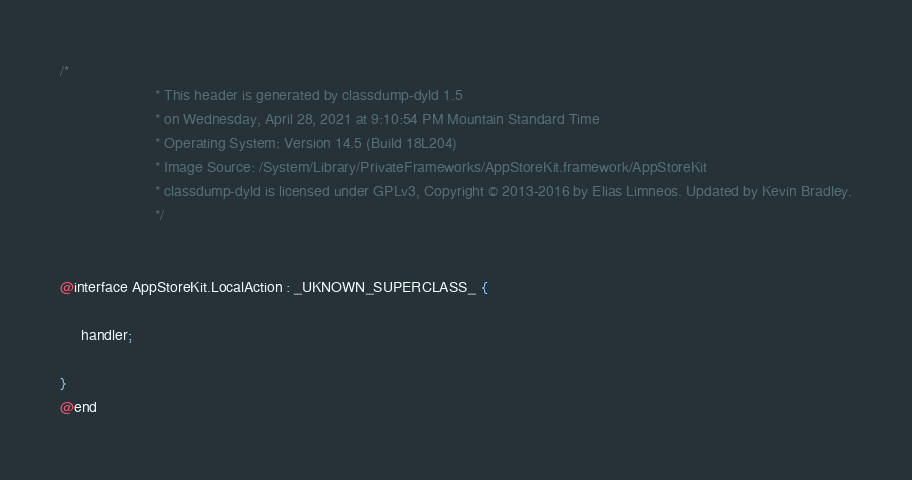Convert code to text. <code><loc_0><loc_0><loc_500><loc_500><_C_>/*
                       * This header is generated by classdump-dyld 1.5
                       * on Wednesday, April 28, 2021 at 9:10:54 PM Mountain Standard Time
                       * Operating System: Version 14.5 (Build 18L204)
                       * Image Source: /System/Library/PrivateFrameworks/AppStoreKit.framework/AppStoreKit
                       * classdump-dyld is licensed under GPLv3, Copyright © 2013-2016 by Elias Limneos. Updated by Kevin Bradley.
                       */


@interface AppStoreKit.LocalAction : _UKNOWN_SUPERCLASS_ {

	 handler;

}
@end

</code> 